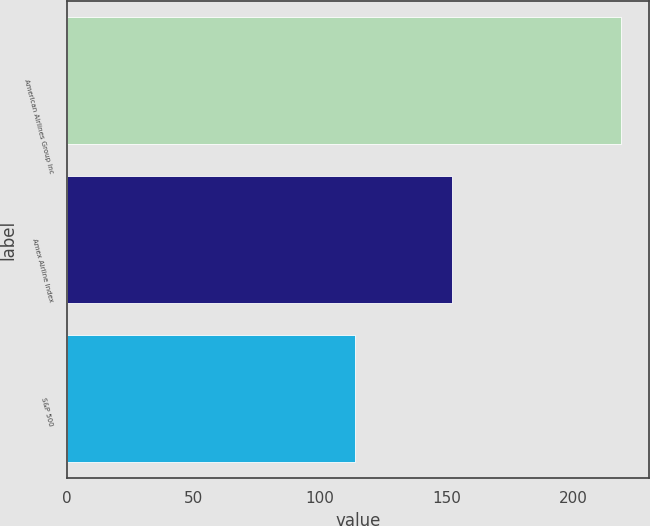Convert chart. <chart><loc_0><loc_0><loc_500><loc_500><bar_chart><fcel>American Airlines Group Inc<fcel>Amex Airline Index<fcel>S&P 500<nl><fcel>219<fcel>152<fcel>114<nl></chart> 